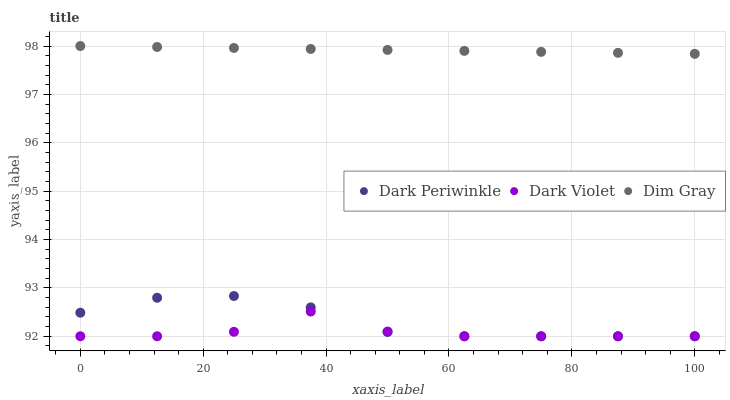Does Dark Violet have the minimum area under the curve?
Answer yes or no. Yes. Does Dim Gray have the maximum area under the curve?
Answer yes or no. Yes. Does Dark Periwinkle have the minimum area under the curve?
Answer yes or no. No. Does Dark Periwinkle have the maximum area under the curve?
Answer yes or no. No. Is Dim Gray the smoothest?
Answer yes or no. Yes. Is Dark Violet the roughest?
Answer yes or no. Yes. Is Dark Periwinkle the smoothest?
Answer yes or no. No. Is Dark Periwinkle the roughest?
Answer yes or no. No. Does Dark Periwinkle have the lowest value?
Answer yes or no. Yes. Does Dim Gray have the highest value?
Answer yes or no. Yes. Does Dark Periwinkle have the highest value?
Answer yes or no. No. Is Dark Periwinkle less than Dim Gray?
Answer yes or no. Yes. Is Dim Gray greater than Dark Periwinkle?
Answer yes or no. Yes. Does Dark Periwinkle intersect Dark Violet?
Answer yes or no. Yes. Is Dark Periwinkle less than Dark Violet?
Answer yes or no. No. Is Dark Periwinkle greater than Dark Violet?
Answer yes or no. No. Does Dark Periwinkle intersect Dim Gray?
Answer yes or no. No. 